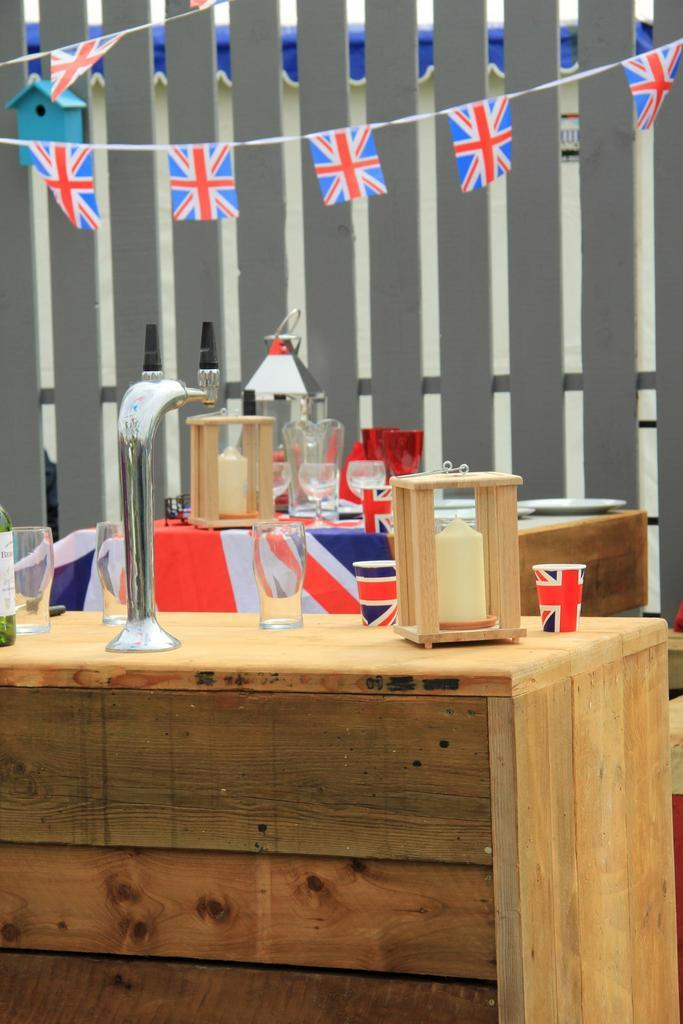What piece of furniture is present in the image? There is a table in the image. What is placed on the table? There is a glass, a stand, a bottle, and a wooden item on the table. What can be seen in the background of the image? There is a wall and flags in the background of the image. How many toes are visible in the image? There are no toes visible in the image. What type of bridge can be seen connecting the two flags in the background? There is no bridge present in the image; only a wall and flags are visible in the background. 